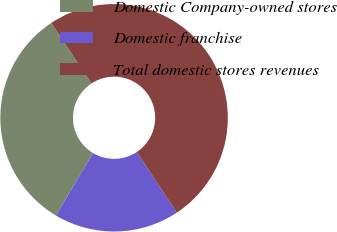<chart> <loc_0><loc_0><loc_500><loc_500><pie_chart><fcel>Domestic Company-owned stores<fcel>Domestic franchise<fcel>Total domestic stores revenues<nl><fcel>32.15%<fcel>17.85%<fcel>50.0%<nl></chart> 